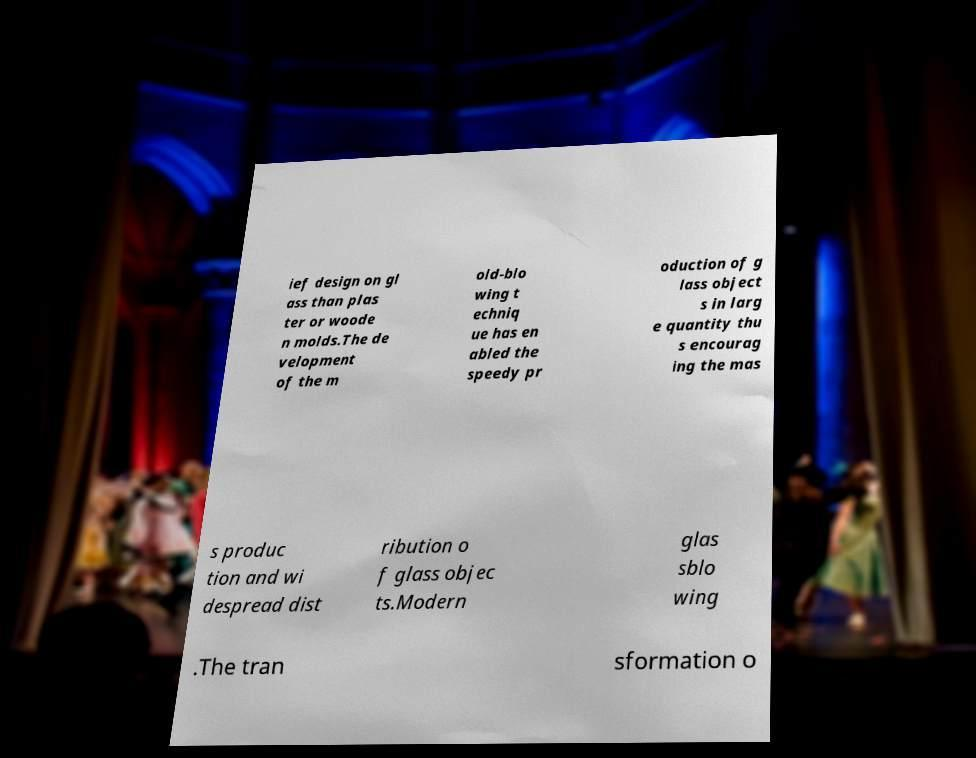There's text embedded in this image that I need extracted. Can you transcribe it verbatim? ief design on gl ass than plas ter or woode n molds.The de velopment of the m old-blo wing t echniq ue has en abled the speedy pr oduction of g lass object s in larg e quantity thu s encourag ing the mas s produc tion and wi despread dist ribution o f glass objec ts.Modern glas sblo wing .The tran sformation o 